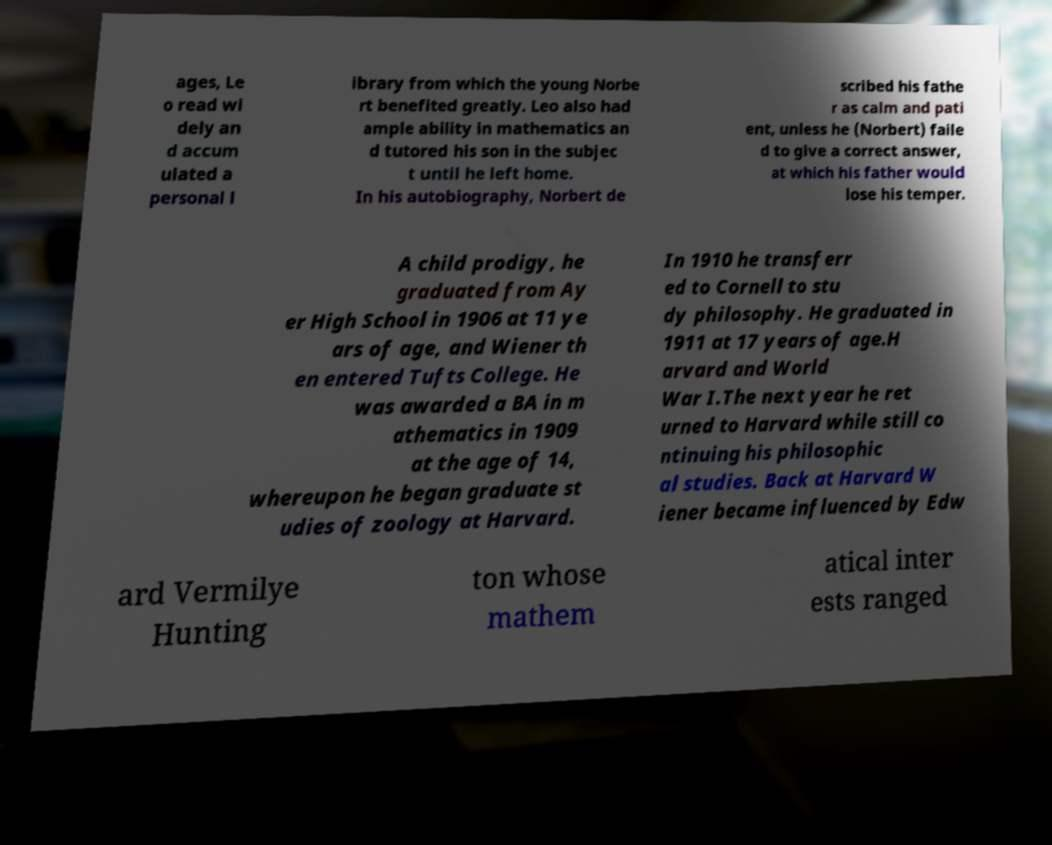For documentation purposes, I need the text within this image transcribed. Could you provide that? ages, Le o read wi dely an d accum ulated a personal l ibrary from which the young Norbe rt benefited greatly. Leo also had ample ability in mathematics an d tutored his son in the subjec t until he left home. In his autobiography, Norbert de scribed his fathe r as calm and pati ent, unless he (Norbert) faile d to give a correct answer, at which his father would lose his temper. A child prodigy, he graduated from Ay er High School in 1906 at 11 ye ars of age, and Wiener th en entered Tufts College. He was awarded a BA in m athematics in 1909 at the age of 14, whereupon he began graduate st udies of zoology at Harvard. In 1910 he transferr ed to Cornell to stu dy philosophy. He graduated in 1911 at 17 years of age.H arvard and World War I.The next year he ret urned to Harvard while still co ntinuing his philosophic al studies. Back at Harvard W iener became influenced by Edw ard Vermilye Hunting ton whose mathem atical inter ests ranged 